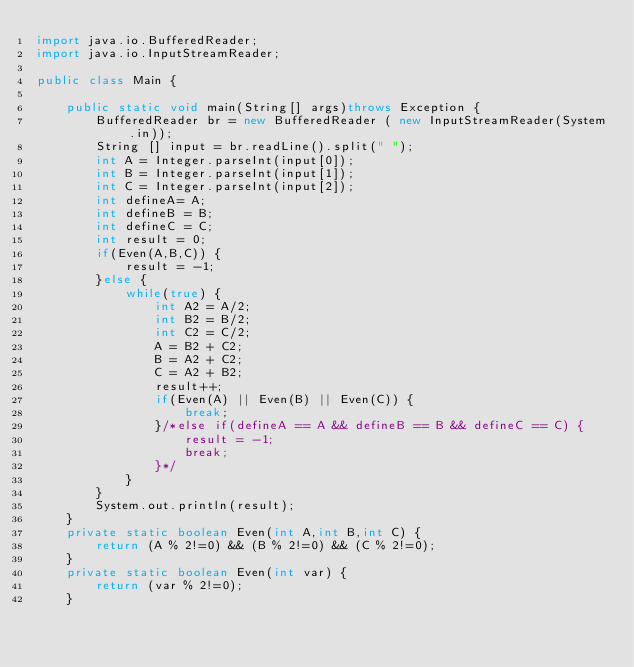Convert code to text. <code><loc_0><loc_0><loc_500><loc_500><_Java_>import java.io.BufferedReader;
import java.io.InputStreamReader;

public class Main {

	public static void main(String[] args)throws Exception {
		BufferedReader br = new BufferedReader ( new InputStreamReader(System.in));
		String [] input = br.readLine().split(" ");
		int A = Integer.parseInt(input[0]);
		int B = Integer.parseInt(input[1]);
		int C = Integer.parseInt(input[2]);
		int defineA= A;
		int defineB = B;
		int defineC = C;
		int result = 0;
		if(Even(A,B,C)) {
			result = -1;
		}else {
			while(true) {
				int A2 = A/2;
				int B2 = B/2;
				int C2 = C/2;
				A = B2 + C2;
				B = A2 + C2;
				C = A2 + B2;
				result++;
				if(Even(A) || Even(B) || Even(C)) {
					break;
				}/*else if(defineA == A && defineB == B && defineC == C) {
					result = -1;
					break;
				}*/
			}
		}
		System.out.println(result);
	}
	private static boolean Even(int A,int B,int C) {
		return (A % 2!=0) && (B % 2!=0) && (C % 2!=0);
	}
	private static boolean Even(int var) {
		return (var % 2!=0);
	}
</code> 